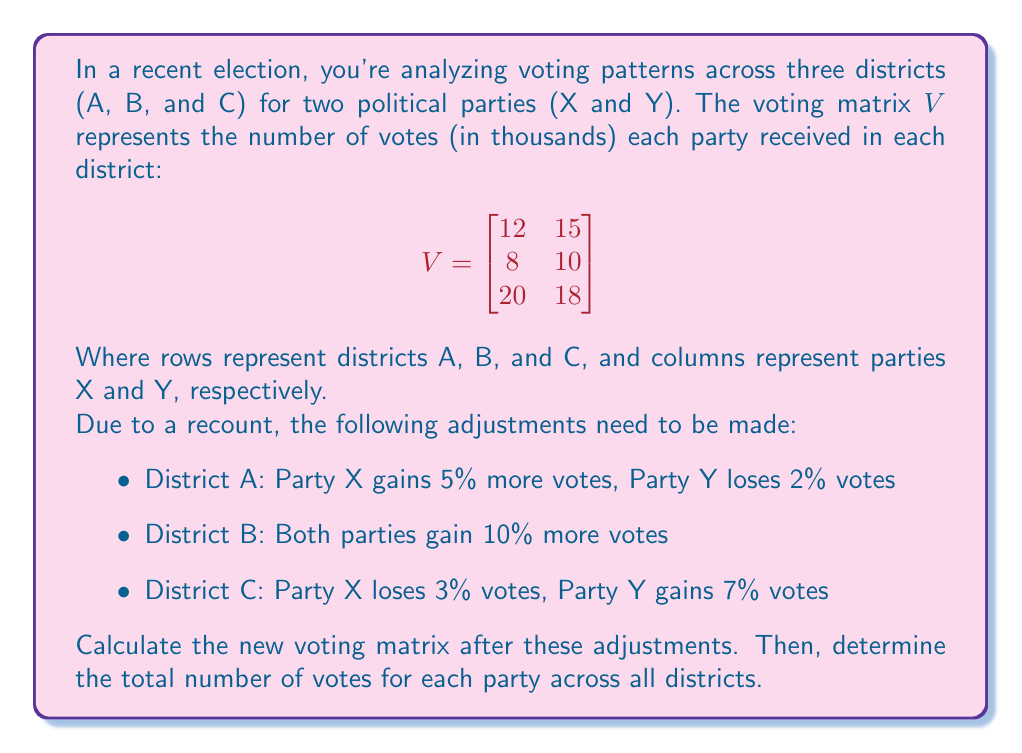Give your solution to this math problem. Let's approach this problem step-by-step:

1) First, we need to create an adjustment matrix $A$ that represents the changes in each district:

   $$A = \begin{bmatrix}
   1.05 & 0.98 \\
   1.10 & 1.10 \\
   0.97 & 1.07
   \end{bmatrix}$$

2) To apply these adjustments, we need to perform element-wise multiplication (Hadamard product) of $V$ and $A$. Let's call the new voting matrix $V_{new}$:

   $$V_{new} = V \circ A$$

3) Let's calculate each element:

   $$V_{new} = \begin{bmatrix}
   12 * 1.05 & 15 * 0.98 \\
   8 * 1.10 & 10 * 1.10 \\
   20 * 0.97 & 18 * 1.07
   \end{bmatrix}$$

   $$= \begin{bmatrix}
   12.60 & 14.70 \\
   8.80 & 11.00 \\
   19.40 & 19.26
   \end{bmatrix}$$

4) To find the total votes for each party, we need to sum the columns of $V_{new}$. We can do this by multiplying $V_{new}$ by a column vector of ones:

   $$\text{Total Votes} = V_{new} \begin{bmatrix} 1 \\ 1 \\ 1 \end{bmatrix}$$

5) Let's perform this calculation:

   $$\begin{bmatrix}
   12.60 & 14.70 \\
   8.80 & 11.00 \\
   19.40 & 19.26
   \end{bmatrix} \begin{bmatrix} 1 \\ 1 \\ 1 \end{bmatrix} = \begin{bmatrix}
   12.60 + 8.80 + 19.40 \\
   14.70 + 11.00 + 19.26
   \end{bmatrix} = \begin{bmatrix}
   40.80 \\
   44.96
   \end{bmatrix}$$

Therefore, after adjustments, Party X received 40.80 thousand votes, and Party Y received 44.96 thousand votes across all districts.
Answer: The new voting matrix after adjustments is:

$$V_{new} = \begin{bmatrix}
12.60 & 14.70 \\
8.80 & 11.00 \\
19.40 & 19.26
\end{bmatrix}$$

The total votes for each party across all districts are:
Party X: 40.80 thousand votes
Party Y: 44.96 thousand votes 